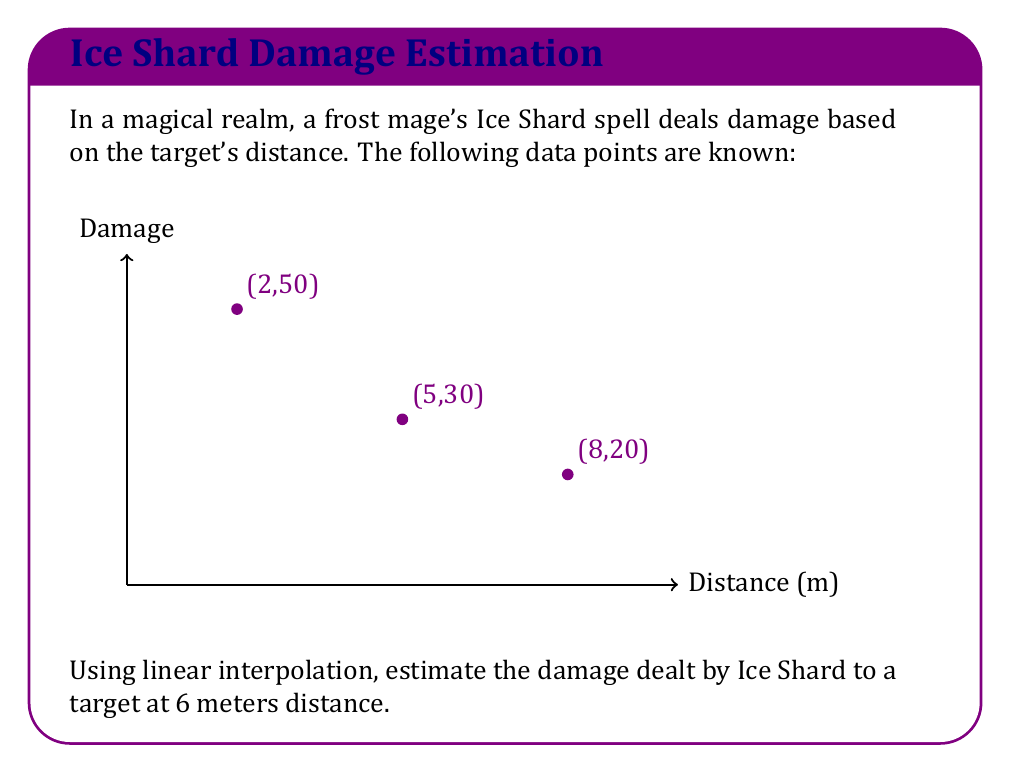Give your solution to this math problem. To solve this problem, we'll use linear interpolation between the known data points (5,30) and (8,20).

1) The formula for linear interpolation is:

   $$y = y_1 + \frac{(x - x_1)(y_2 - y_1)}{x_2 - x_1}$$

   where $(x_1, y_1)$ and $(x_2, y_2)$ are the known points, and $(x, y)$ is the point we're interpolating.

2) In this case:
   $(x_1, y_1) = (5, 30)$
   $(x_2, y_2) = (8, 20)$
   $x = 6$ (the distance we're estimating for)

3) Plugging these values into the formula:

   $$y = 30 + \frac{(6 - 5)(20 - 30)}{8 - 5}$$

4) Simplify:
   $$y = 30 + \frac{1 \cdot (-10)}{3} = 30 - \frac{10}{3}$$

5) Calculate:
   $$y = 30 - 3.33 = 26.67$$

Therefore, the estimated damage at 6 meters is approximately 26.67.
Answer: 26.67 damage 